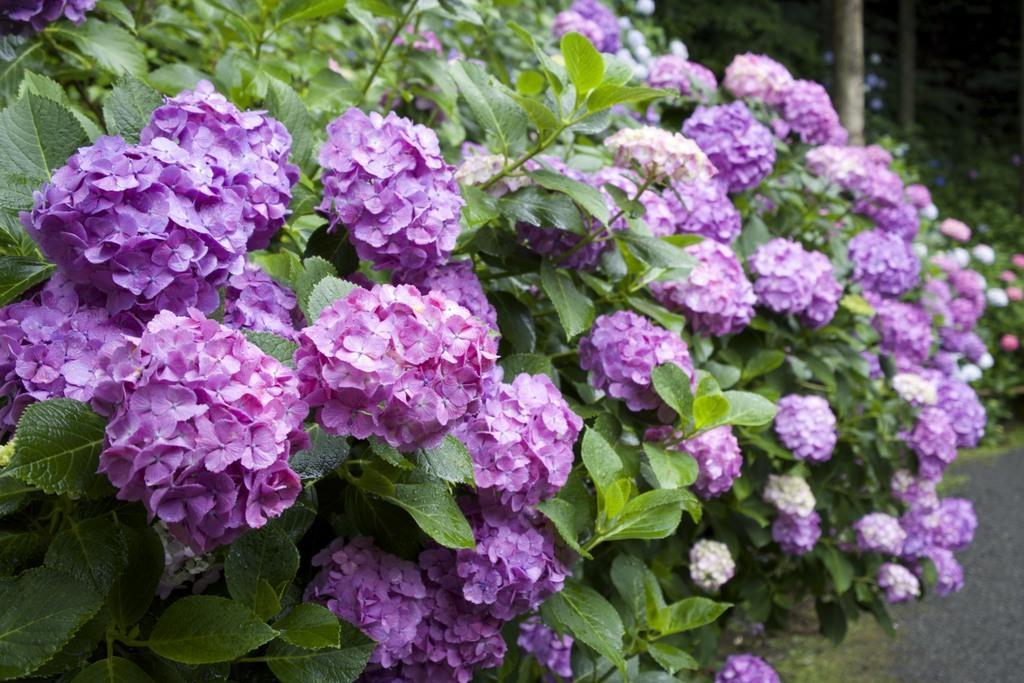Describe this image in one or two sentences. In this picture, I can see a bunch of flowers,leaves, after that i can see a stem and also a road. 